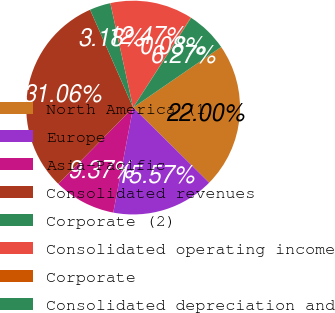Convert chart to OTSL. <chart><loc_0><loc_0><loc_500><loc_500><pie_chart><fcel>North America (1)<fcel>Europe<fcel>Asia-Pacific<fcel>Consolidated revenues<fcel>Corporate (2)<fcel>Consolidated operating income<fcel>Corporate<fcel>Consolidated depreciation and<nl><fcel>22.0%<fcel>15.57%<fcel>9.37%<fcel>31.06%<fcel>3.18%<fcel>12.47%<fcel>0.08%<fcel>6.27%<nl></chart> 